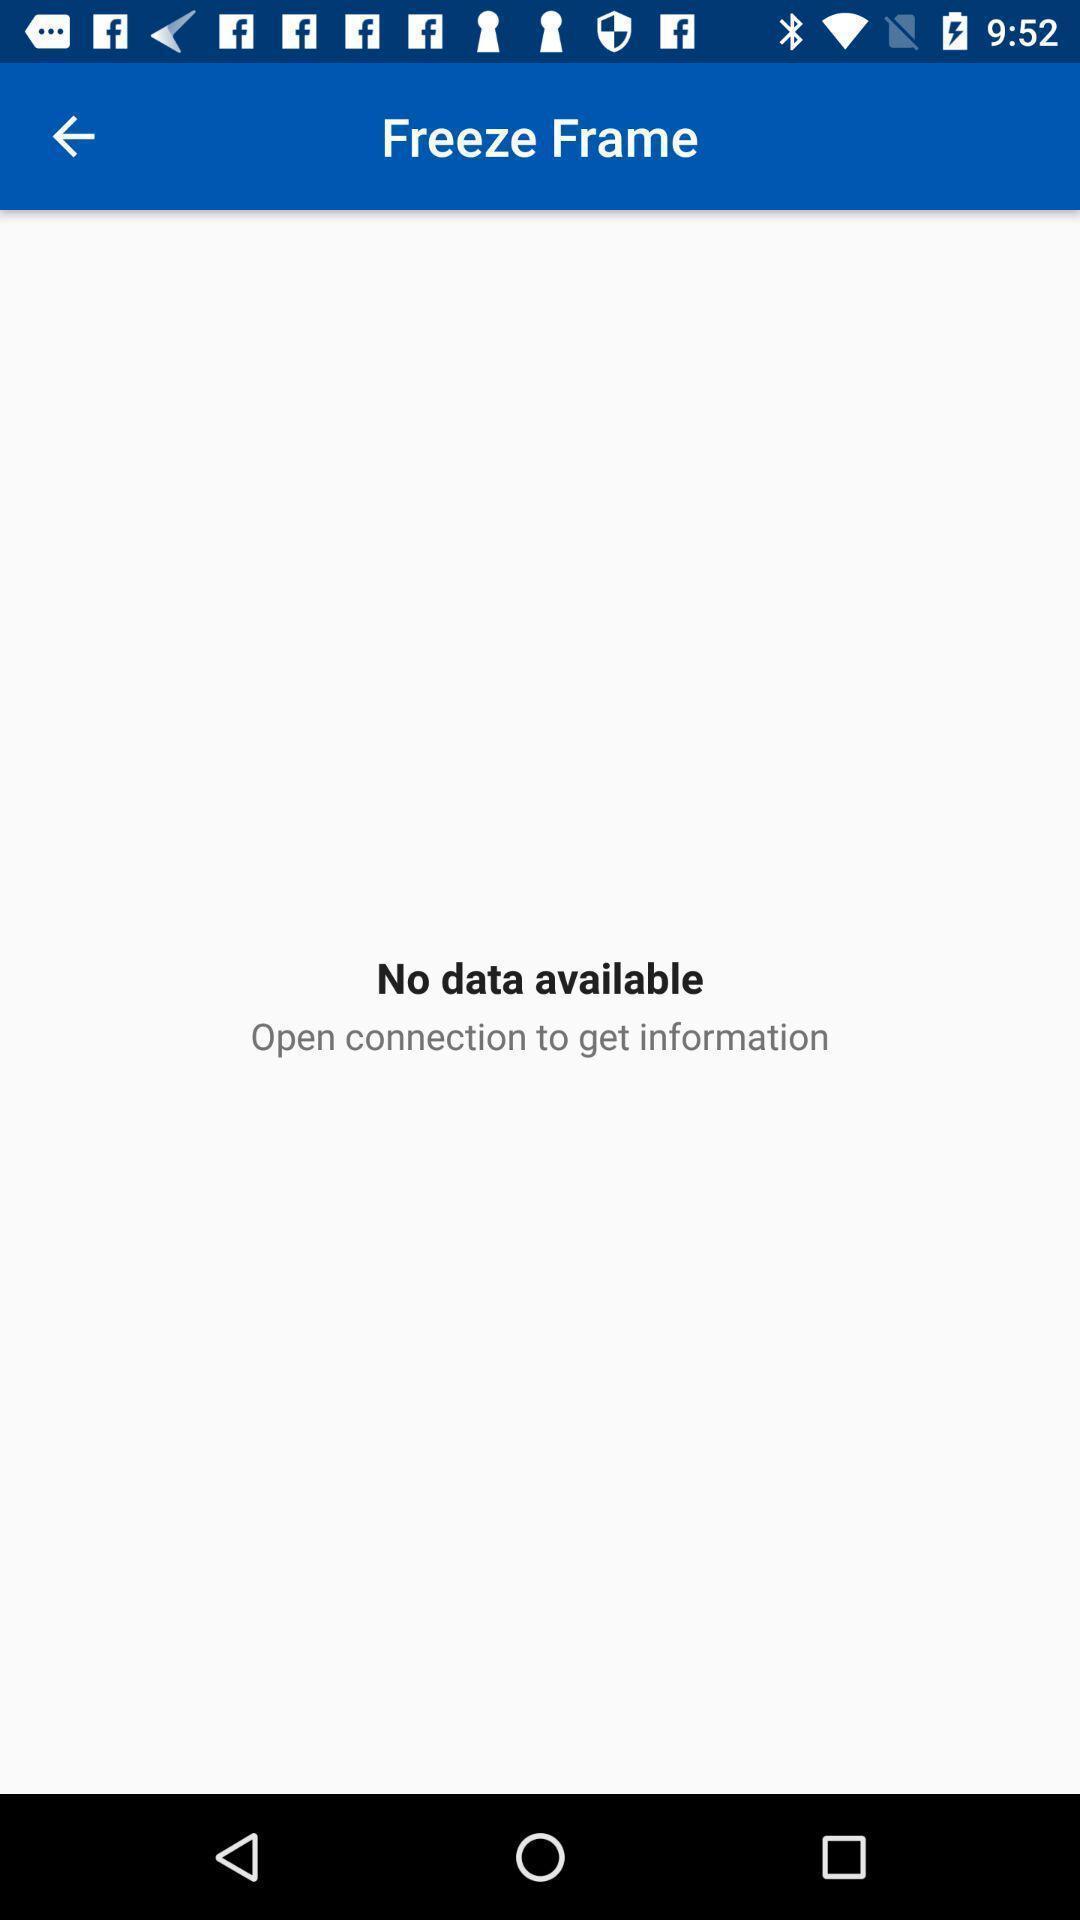Describe the key features of this screenshot. Page displaying with no data available in application. 